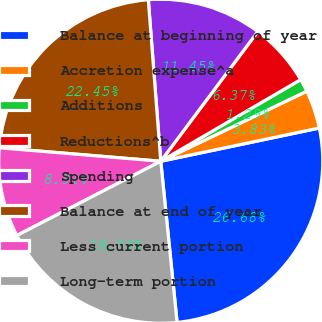Convert chart to OTSL. <chart><loc_0><loc_0><loc_500><loc_500><pie_chart><fcel>Balance at beginning of year<fcel>Accretion expense^a<fcel>Additions<fcel>Reductions^b<fcel>Spending<fcel>Balance at end of year<fcel>Less current portion<fcel>Long-term portion<nl><fcel>26.69%<fcel>3.83%<fcel>1.29%<fcel>6.37%<fcel>11.45%<fcel>22.45%<fcel>8.91%<fcel>19.03%<nl></chart> 